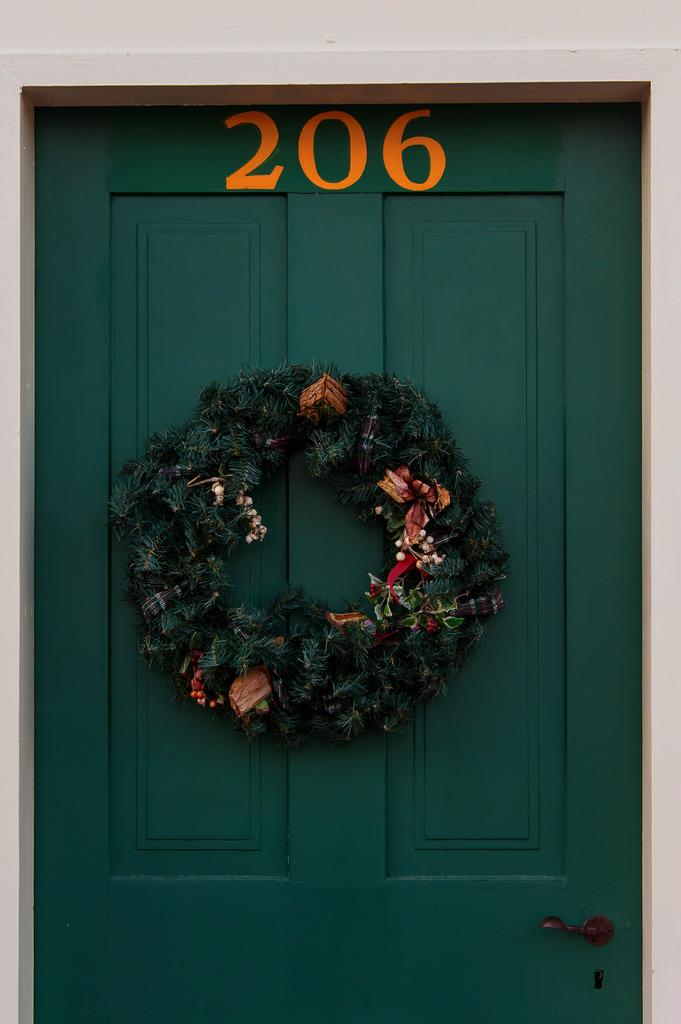What is attached to the door in the image? There is a garland attached to the door in the image. What color is the door? The door is green. What number and color can be seen at the top of the door? The number "206" is present at the top of the door in orange color. What type of crook can be seen working on the door's rhythm in the image? There is no crook or rhythm present in the image; it only features a door with a garland and a number. 